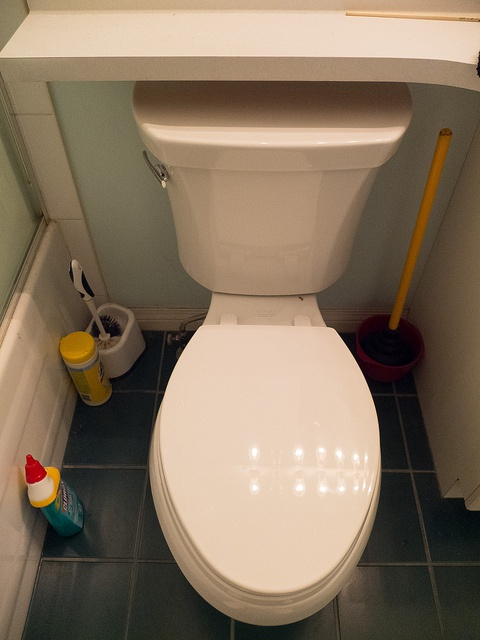Describe the objects in this image and their specific colors. I can see a toilet in gray and tan tones in this image. 